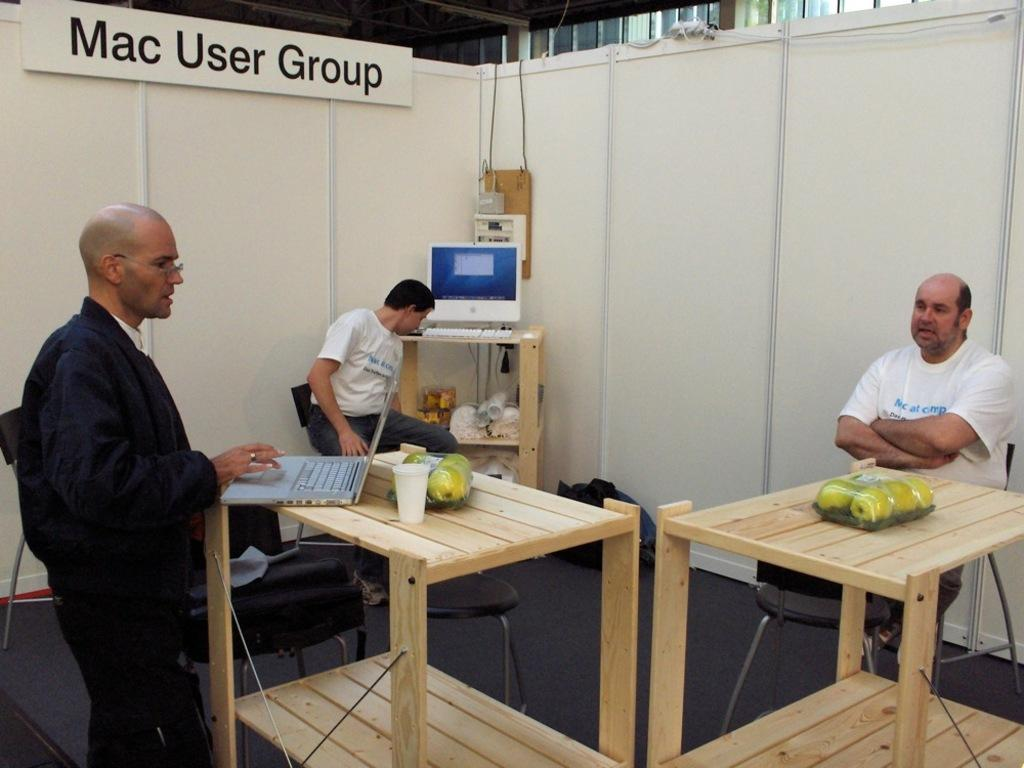<image>
Write a terse but informative summary of the picture. A small cubical with three men inside and a sign that says Mac User Group 